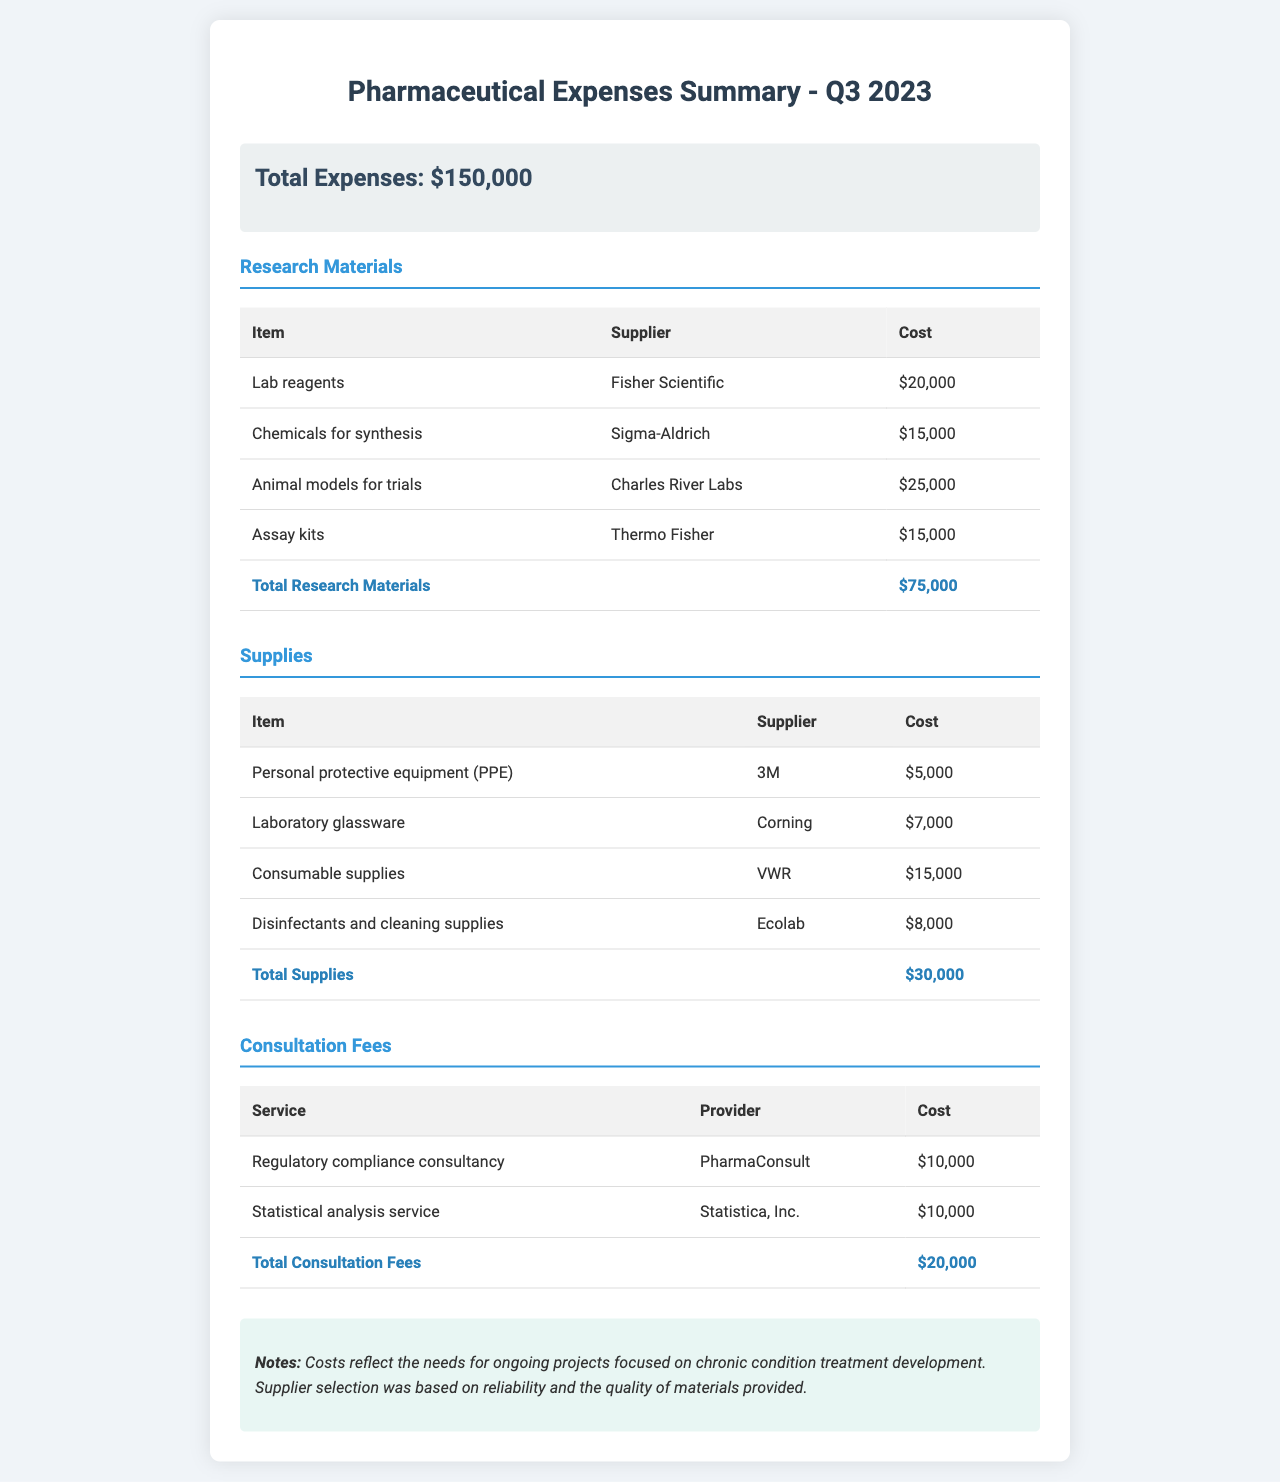What is the total expenses? The total expenses is stated clearly in the summary section, which is $150,000.
Answer: $150,000 How much was spent on Animal models for trials? The cost for Animal models for trials is detailed in the Research Materials section, which lists it as $25,000.
Answer: $25,000 What is the supplier for Lab reagents? The supplier for Lab reagents is named in the Research Materials section, which indicates it is Fisher Scientific.
Answer: Fisher Scientific What is the total cost of Supplies? The total cost of Supplies is calculated and provided in the Supplies section as $30,000.
Answer: $30,000 Which company provided the Disinfectants and cleaning supplies? The company providing Disinfectants and cleaning supplies is listed in the Supplies section as Ecolab.
Answer: Ecolab How much did the Regulatory compliance consultancy cost? The cost for Regulatory compliance consultancy is specified in the Consultation Fees section as $10,000.
Answer: $10,000 What category has the highest expense? By comparing the totals in each section, Research Materials has the highest expense at $75,000.
Answer: Research Materials How many types of expenses are detailed in the document? The document details three types of expenses: Research Materials, Supplies, and Consultation Fees.
Answer: Three What was the purpose of the expenditures according to the notes? The notes indicate that the costs reflect the needs for ongoing projects focused on chronic condition treatment development.
Answer: Ongoing projects for chronic condition treatment 